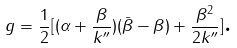Convert formula to latex. <formula><loc_0><loc_0><loc_500><loc_500>g = \frac { 1 } { 2 } [ ( \alpha + \frac { \beta } { k ^ { \prime \prime } } ) ( \bar { \beta } - \beta ) + \frac { \beta ^ { 2 } } { 2 k ^ { \prime \prime } } ] \text {.}</formula> 